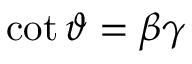<formula> <loc_0><loc_0><loc_500><loc_500>\cot \vartheta = \beta \gamma</formula> 